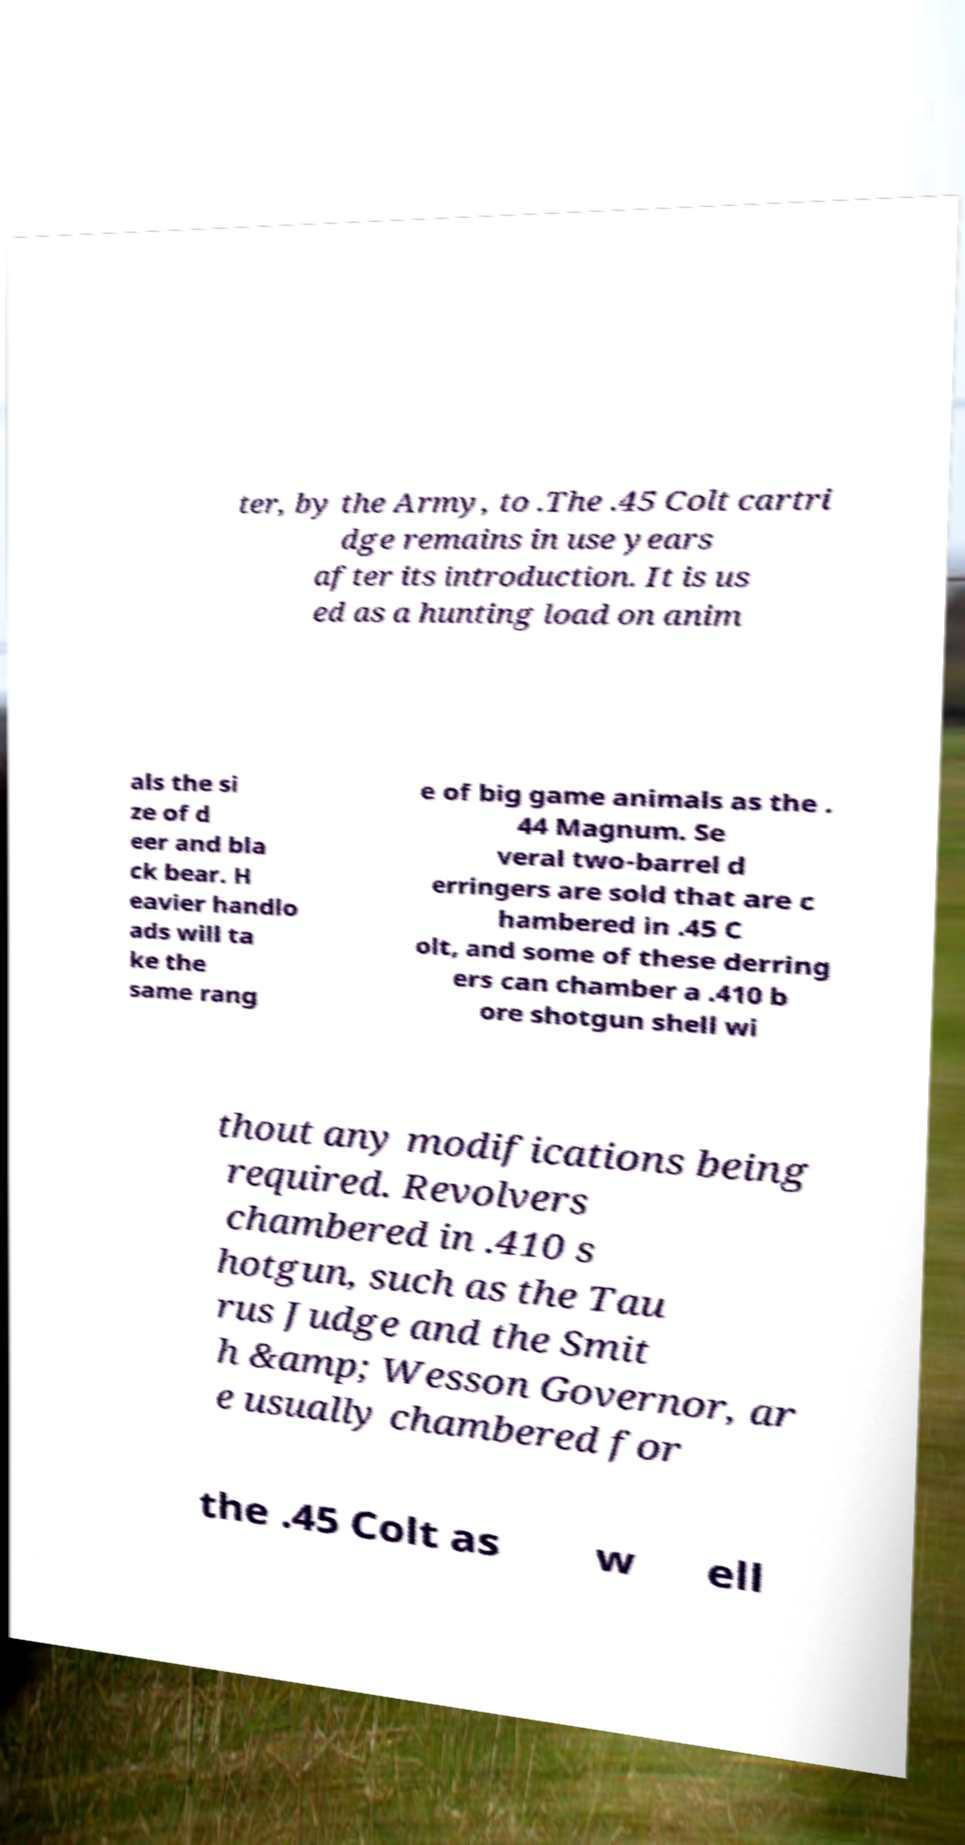Can you read and provide the text displayed in the image?This photo seems to have some interesting text. Can you extract and type it out for me? ter, by the Army, to .The .45 Colt cartri dge remains in use years after its introduction. It is us ed as a hunting load on anim als the si ze of d eer and bla ck bear. H eavier handlo ads will ta ke the same rang e of big game animals as the . 44 Magnum. Se veral two-barrel d erringers are sold that are c hambered in .45 C olt, and some of these derring ers can chamber a .410 b ore shotgun shell wi thout any modifications being required. Revolvers chambered in .410 s hotgun, such as the Tau rus Judge and the Smit h &amp; Wesson Governor, ar e usually chambered for the .45 Colt as w ell 